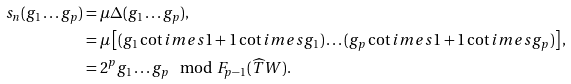<formula> <loc_0><loc_0><loc_500><loc_500>s _ { n } ( g _ { 1 } \dots g _ { p } ) & = \mu \Delta ( g _ { 1 } \dots g _ { p } ) , \\ & = \mu \left [ ( g _ { 1 } \cot i m e s 1 + 1 \cot i m e s g _ { 1 } ) \dots ( g _ { p } \cot i m e s 1 + 1 \cot i m e s g _ { p } ) \right ] , \\ & = 2 ^ { p } g _ { 1 } \dots g _ { p } \mod F _ { p - 1 } ( \widehat { T } W ) . \\</formula> 